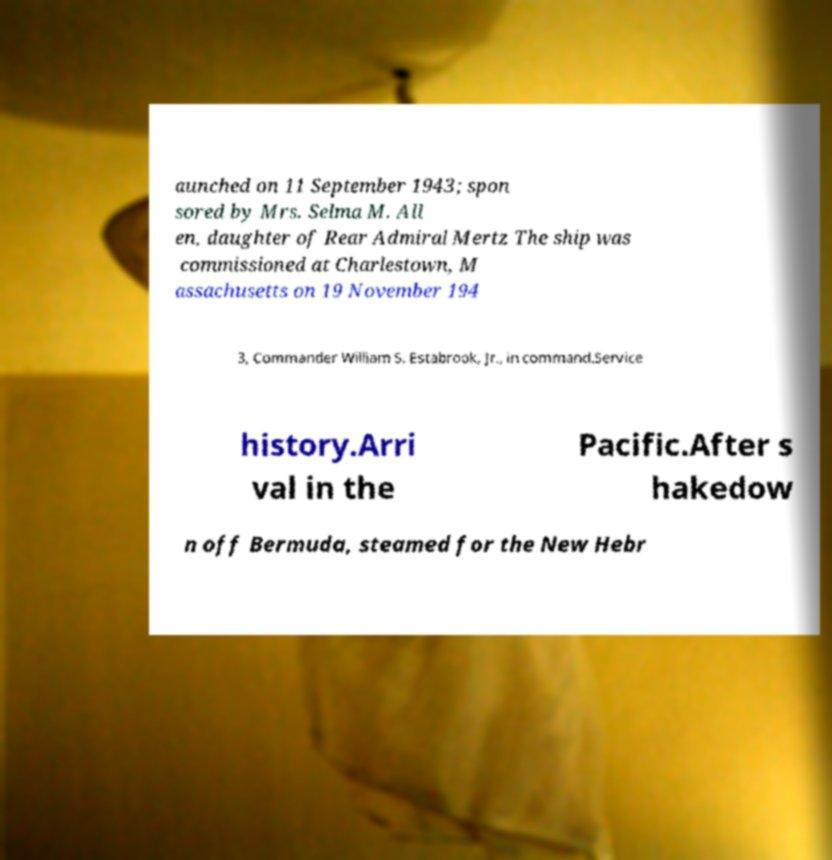Could you assist in decoding the text presented in this image and type it out clearly? aunched on 11 September 1943; spon sored by Mrs. Selma M. All en, daughter of Rear Admiral Mertz The ship was commissioned at Charlestown, M assachusetts on 19 November 194 3, Commander William S. Estabrook, Jr., in command.Service history.Arri val in the Pacific.After s hakedow n off Bermuda, steamed for the New Hebr 